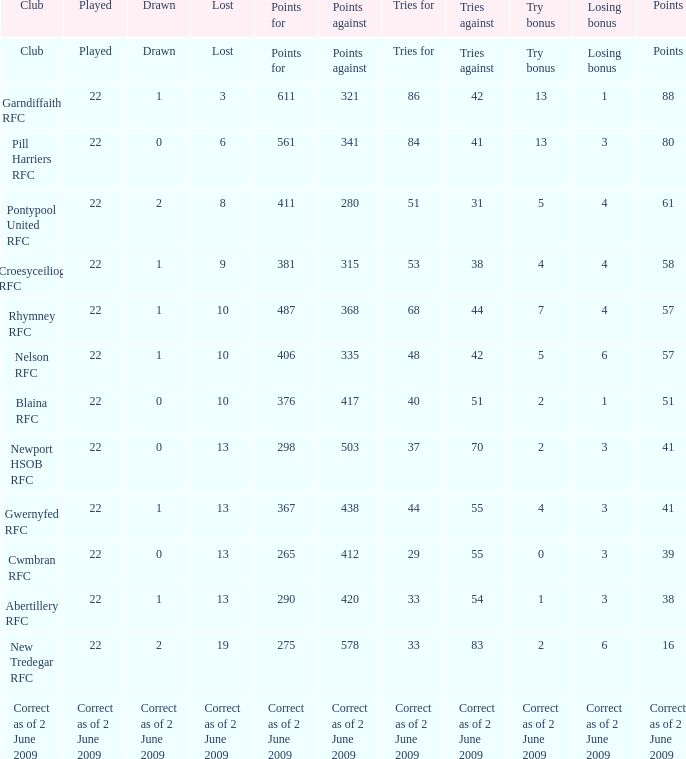Which club has 275 points? New Tredegar RFC. 